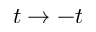<formula> <loc_0><loc_0><loc_500><loc_500>t \to - t</formula> 